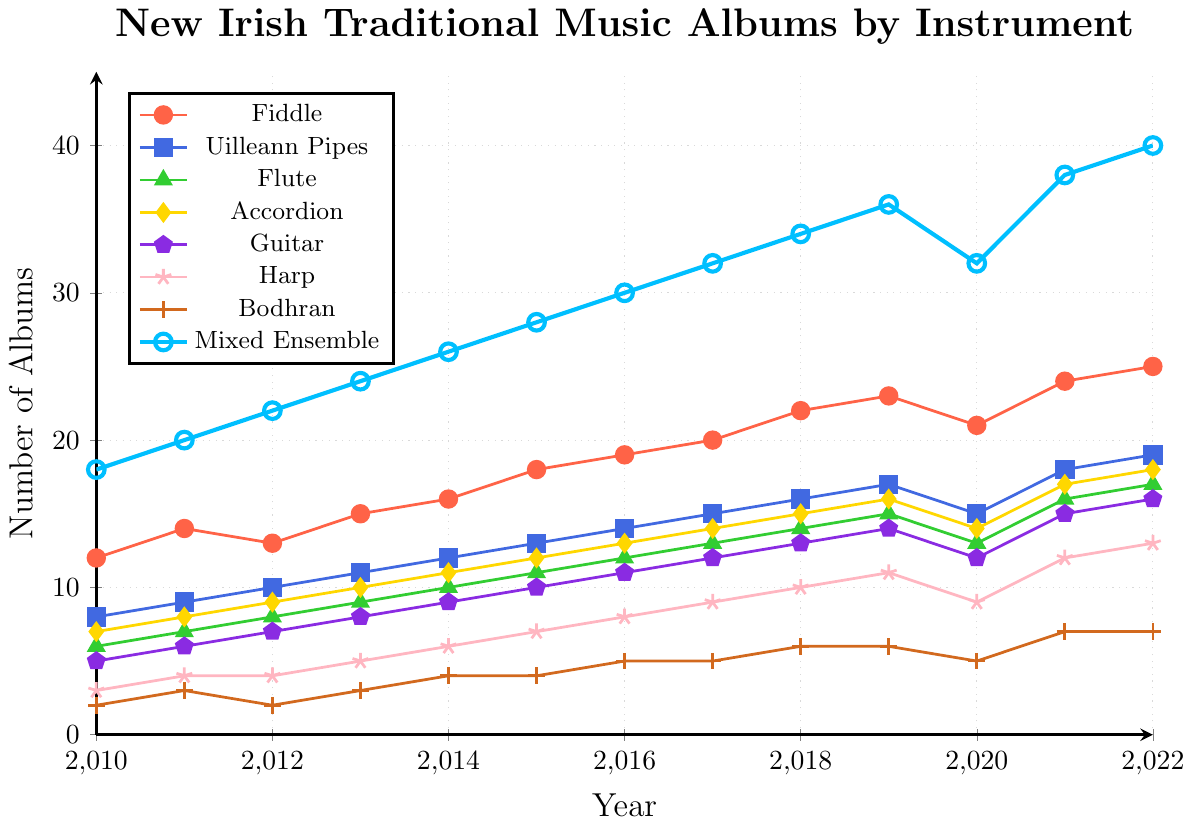When was the highest number of Mixed Ensemble albums released? The highest point on the Mixed Ensemble line is at 40 albums. Locate this point on the x-axis, which intersects at the year 2022.
Answer: 2022 Which instrument had the lowest number of albums released in 2022? Check the values at the year 2022 for all instruments. The Bodhran and Harp both had 7 albums in 2022. Compare all values, and the Bodhran has the lowest number.
Answer: Bodhran By how many did the number of Fiddle albums increase from 2010 to 2022? The number of Fiddle albums in 2010 was 12 and in 2022 it was 25. Subtract the 2010 value from the 2022 value: 25 - 12 = 13.
Answer: 13 Which year saw a decline in the number of new Uilleann Pipes albums compared to the previous year? Examine the Uilleann Pipes line chart year by year. Between 2019 and 2020, the number dropped from 17 to 15.
Answer: 2020 Compare the number of Accordion and Guitar albums released in 2019. Which was higher? Look at the values for 2019 for Accordion (16) and Guitar (14). Since 16 is greater than 14, more Accordion albums were released.
Answer: Accordion What is the average number of Flute albums released from 2010 to 2022? Add up the number of Flute albums for each year (6+7+8+9+10+11+12+13+14+15+13+16+17), getting 151, then divide by the number of years (13): 151/13 ≈ 11.6.
Answer: 11.6 What is the difference in the number of albums between Fiddle and Harp in 2022? For 2022, the number of Fiddle albums is 25 and Harp albums is 13. Subtract Harp from Fiddle: 25 - 13 = 12.
Answer: 12 Describe the trend in the number of Mixed Ensemble albums from 2010 to 2022. The number of Mixed Ensemble albums released increased from 18 in 2010 to 40 in 2022, showing a consistent upwards trend with a slight decline in 2020.
Answer: Increasing trend How many total new albums were released in 2015? Add the number of albums for each instrument in 2015: 18 (Fiddle) + 13 (Uilleann Pipes) + 11 (Flute) + 12 (Accordion) + 10 (Guitar) + 7 (Harp) + 4 (Bodhran) + 28 (Mixed Ensemble) = 103.
Answer: 103 